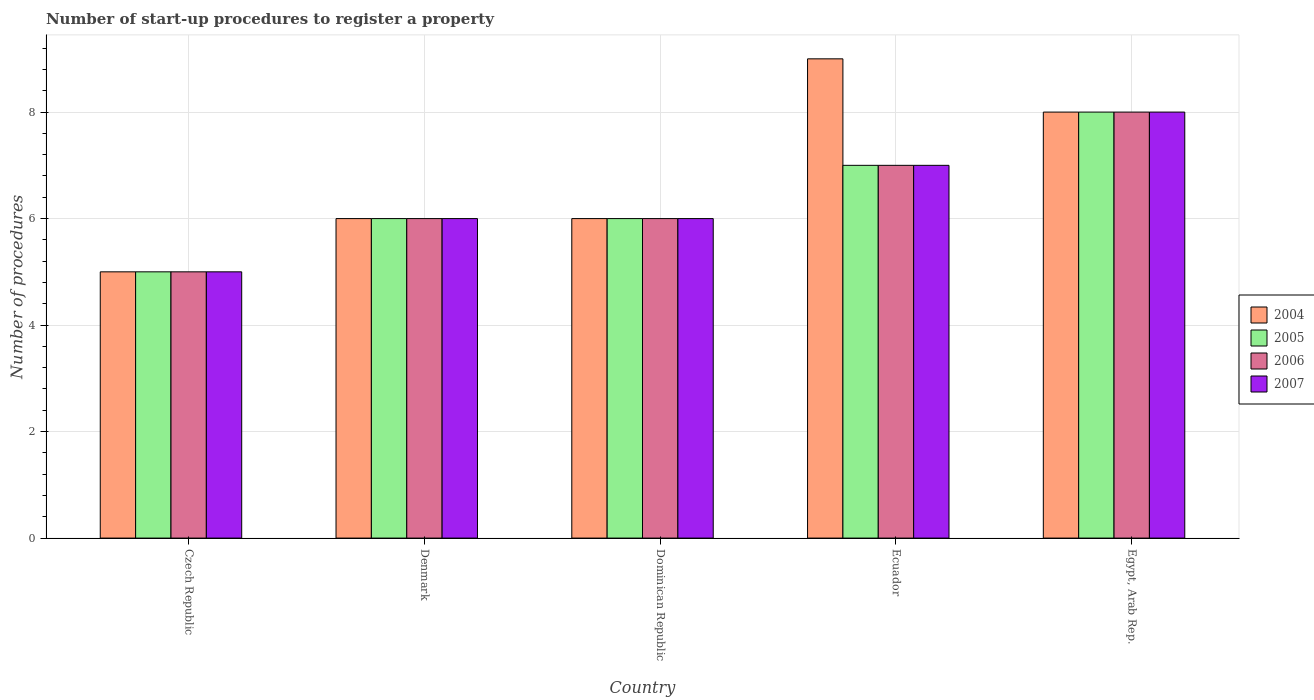How many different coloured bars are there?
Provide a short and direct response. 4. Are the number of bars on each tick of the X-axis equal?
Keep it short and to the point. Yes. What is the label of the 4th group of bars from the left?
Give a very brief answer. Ecuador. In which country was the number of procedures required to register a property in 2006 maximum?
Your response must be concise. Egypt, Arab Rep. In which country was the number of procedures required to register a property in 2005 minimum?
Provide a succinct answer. Czech Republic. What is the difference between the number of procedures required to register a property in 2004 in Dominican Republic and that in Egypt, Arab Rep.?
Provide a succinct answer. -2. What is the average number of procedures required to register a property in 2006 per country?
Your answer should be compact. 6.4. What is the difference between the number of procedures required to register a property of/in 2005 and number of procedures required to register a property of/in 2004 in Ecuador?
Give a very brief answer. -2. In how many countries, is the number of procedures required to register a property in 2007 greater than 3.6?
Offer a very short reply. 5. What is the ratio of the number of procedures required to register a property in 2006 in Dominican Republic to that in Ecuador?
Offer a very short reply. 0.86. What is the difference between the highest and the second highest number of procedures required to register a property in 2007?
Make the answer very short. 2. What is the difference between the highest and the lowest number of procedures required to register a property in 2005?
Provide a succinct answer. 3. In how many countries, is the number of procedures required to register a property in 2004 greater than the average number of procedures required to register a property in 2004 taken over all countries?
Your answer should be compact. 2. Is the sum of the number of procedures required to register a property in 2005 in Denmark and Egypt, Arab Rep. greater than the maximum number of procedures required to register a property in 2007 across all countries?
Offer a terse response. Yes. Is it the case that in every country, the sum of the number of procedures required to register a property in 2005 and number of procedures required to register a property in 2006 is greater than the sum of number of procedures required to register a property in 2004 and number of procedures required to register a property in 2007?
Your answer should be very brief. No. What does the 1st bar from the left in Czech Republic represents?
Offer a very short reply. 2004. What does the 4th bar from the right in Ecuador represents?
Offer a terse response. 2004. Is it the case that in every country, the sum of the number of procedures required to register a property in 2004 and number of procedures required to register a property in 2005 is greater than the number of procedures required to register a property in 2006?
Ensure brevity in your answer.  Yes. How many bars are there?
Your answer should be very brief. 20. Are all the bars in the graph horizontal?
Provide a short and direct response. No. Does the graph contain grids?
Your answer should be compact. Yes. Where does the legend appear in the graph?
Your response must be concise. Center right. How many legend labels are there?
Offer a terse response. 4. How are the legend labels stacked?
Your response must be concise. Vertical. What is the title of the graph?
Your response must be concise. Number of start-up procedures to register a property. What is the label or title of the X-axis?
Offer a very short reply. Country. What is the label or title of the Y-axis?
Provide a succinct answer. Number of procedures. What is the Number of procedures in 2004 in Czech Republic?
Your answer should be very brief. 5. What is the Number of procedures of 2005 in Czech Republic?
Give a very brief answer. 5. What is the Number of procedures of 2007 in Denmark?
Provide a succinct answer. 6. What is the Number of procedures in 2004 in Dominican Republic?
Give a very brief answer. 6. What is the Number of procedures of 2005 in Dominican Republic?
Your response must be concise. 6. What is the Number of procedures of 2007 in Dominican Republic?
Provide a succinct answer. 6. What is the Number of procedures in 2004 in Ecuador?
Provide a short and direct response. 9. What is the Number of procedures of 2007 in Ecuador?
Offer a terse response. 7. What is the Number of procedures in 2004 in Egypt, Arab Rep.?
Provide a succinct answer. 8. What is the Number of procedures of 2005 in Egypt, Arab Rep.?
Your response must be concise. 8. What is the Number of procedures of 2006 in Egypt, Arab Rep.?
Your response must be concise. 8. What is the Number of procedures in 2007 in Egypt, Arab Rep.?
Keep it short and to the point. 8. Across all countries, what is the maximum Number of procedures in 2004?
Your response must be concise. 9. Across all countries, what is the maximum Number of procedures of 2005?
Offer a terse response. 8. Across all countries, what is the maximum Number of procedures in 2007?
Provide a short and direct response. 8. Across all countries, what is the minimum Number of procedures of 2006?
Provide a short and direct response. 5. What is the total Number of procedures of 2004 in the graph?
Provide a succinct answer. 34. What is the total Number of procedures of 2005 in the graph?
Offer a terse response. 32. What is the total Number of procedures of 2007 in the graph?
Make the answer very short. 32. What is the difference between the Number of procedures in 2005 in Czech Republic and that in Dominican Republic?
Ensure brevity in your answer.  -1. What is the difference between the Number of procedures in 2006 in Czech Republic and that in Dominican Republic?
Make the answer very short. -1. What is the difference between the Number of procedures of 2007 in Czech Republic and that in Dominican Republic?
Provide a short and direct response. -1. What is the difference between the Number of procedures of 2004 in Czech Republic and that in Ecuador?
Provide a succinct answer. -4. What is the difference between the Number of procedures of 2007 in Czech Republic and that in Ecuador?
Your response must be concise. -2. What is the difference between the Number of procedures in 2005 in Czech Republic and that in Egypt, Arab Rep.?
Your response must be concise. -3. What is the difference between the Number of procedures in 2007 in Czech Republic and that in Egypt, Arab Rep.?
Provide a short and direct response. -3. What is the difference between the Number of procedures of 2006 in Denmark and that in Dominican Republic?
Ensure brevity in your answer.  0. What is the difference between the Number of procedures of 2004 in Denmark and that in Ecuador?
Offer a terse response. -3. What is the difference between the Number of procedures of 2007 in Denmark and that in Ecuador?
Make the answer very short. -1. What is the difference between the Number of procedures of 2004 in Denmark and that in Egypt, Arab Rep.?
Ensure brevity in your answer.  -2. What is the difference between the Number of procedures of 2005 in Denmark and that in Egypt, Arab Rep.?
Provide a succinct answer. -2. What is the difference between the Number of procedures of 2007 in Denmark and that in Egypt, Arab Rep.?
Ensure brevity in your answer.  -2. What is the difference between the Number of procedures of 2007 in Dominican Republic and that in Ecuador?
Keep it short and to the point. -1. What is the difference between the Number of procedures of 2005 in Dominican Republic and that in Egypt, Arab Rep.?
Your response must be concise. -2. What is the difference between the Number of procedures of 2007 in Dominican Republic and that in Egypt, Arab Rep.?
Your response must be concise. -2. What is the difference between the Number of procedures in 2006 in Ecuador and that in Egypt, Arab Rep.?
Keep it short and to the point. -1. What is the difference between the Number of procedures of 2004 in Czech Republic and the Number of procedures of 2005 in Denmark?
Make the answer very short. -1. What is the difference between the Number of procedures of 2004 in Czech Republic and the Number of procedures of 2007 in Denmark?
Give a very brief answer. -1. What is the difference between the Number of procedures of 2005 in Czech Republic and the Number of procedures of 2007 in Denmark?
Keep it short and to the point. -1. What is the difference between the Number of procedures in 2004 in Czech Republic and the Number of procedures in 2006 in Dominican Republic?
Provide a succinct answer. -1. What is the difference between the Number of procedures of 2004 in Czech Republic and the Number of procedures of 2007 in Dominican Republic?
Give a very brief answer. -1. What is the difference between the Number of procedures of 2005 in Czech Republic and the Number of procedures of 2007 in Dominican Republic?
Keep it short and to the point. -1. What is the difference between the Number of procedures in 2006 in Czech Republic and the Number of procedures in 2007 in Dominican Republic?
Keep it short and to the point. -1. What is the difference between the Number of procedures of 2004 in Czech Republic and the Number of procedures of 2005 in Ecuador?
Your response must be concise. -2. What is the difference between the Number of procedures in 2004 in Czech Republic and the Number of procedures in 2007 in Ecuador?
Offer a terse response. -2. What is the difference between the Number of procedures of 2005 in Czech Republic and the Number of procedures of 2006 in Ecuador?
Make the answer very short. -2. What is the difference between the Number of procedures in 2006 in Czech Republic and the Number of procedures in 2007 in Ecuador?
Provide a short and direct response. -2. What is the difference between the Number of procedures of 2004 in Czech Republic and the Number of procedures of 2006 in Egypt, Arab Rep.?
Give a very brief answer. -3. What is the difference between the Number of procedures of 2004 in Czech Republic and the Number of procedures of 2007 in Egypt, Arab Rep.?
Your answer should be very brief. -3. What is the difference between the Number of procedures of 2005 in Czech Republic and the Number of procedures of 2006 in Egypt, Arab Rep.?
Your answer should be very brief. -3. What is the difference between the Number of procedures in 2004 in Denmark and the Number of procedures in 2006 in Dominican Republic?
Provide a succinct answer. 0. What is the difference between the Number of procedures of 2005 in Denmark and the Number of procedures of 2006 in Dominican Republic?
Offer a terse response. 0. What is the difference between the Number of procedures in 2004 in Denmark and the Number of procedures in 2005 in Ecuador?
Your answer should be compact. -1. What is the difference between the Number of procedures of 2004 in Denmark and the Number of procedures of 2006 in Ecuador?
Your answer should be very brief. -1. What is the difference between the Number of procedures of 2004 in Denmark and the Number of procedures of 2007 in Ecuador?
Your answer should be compact. -1. What is the difference between the Number of procedures in 2006 in Denmark and the Number of procedures in 2007 in Ecuador?
Provide a succinct answer. -1. What is the difference between the Number of procedures in 2004 in Denmark and the Number of procedures in 2007 in Egypt, Arab Rep.?
Your answer should be compact. -2. What is the difference between the Number of procedures in 2005 in Denmark and the Number of procedures in 2006 in Egypt, Arab Rep.?
Offer a very short reply. -2. What is the difference between the Number of procedures of 2005 in Dominican Republic and the Number of procedures of 2006 in Ecuador?
Give a very brief answer. -1. What is the difference between the Number of procedures in 2004 in Dominican Republic and the Number of procedures in 2005 in Egypt, Arab Rep.?
Offer a terse response. -2. What is the difference between the Number of procedures in 2004 in Dominican Republic and the Number of procedures in 2007 in Egypt, Arab Rep.?
Provide a short and direct response. -2. What is the difference between the Number of procedures in 2005 in Dominican Republic and the Number of procedures in 2006 in Egypt, Arab Rep.?
Keep it short and to the point. -2. What is the difference between the Number of procedures of 2006 in Dominican Republic and the Number of procedures of 2007 in Egypt, Arab Rep.?
Provide a short and direct response. -2. What is the difference between the Number of procedures of 2005 in Ecuador and the Number of procedures of 2007 in Egypt, Arab Rep.?
Provide a succinct answer. -1. What is the average Number of procedures in 2004 per country?
Provide a succinct answer. 6.8. What is the difference between the Number of procedures in 2004 and Number of procedures in 2005 in Czech Republic?
Your answer should be very brief. 0. What is the difference between the Number of procedures of 2004 and Number of procedures of 2006 in Czech Republic?
Ensure brevity in your answer.  0. What is the difference between the Number of procedures in 2005 and Number of procedures in 2006 in Czech Republic?
Offer a terse response. 0. What is the difference between the Number of procedures in 2005 and Number of procedures in 2007 in Czech Republic?
Ensure brevity in your answer.  0. What is the difference between the Number of procedures in 2004 and Number of procedures in 2005 in Denmark?
Your answer should be compact. 0. What is the difference between the Number of procedures of 2005 and Number of procedures of 2007 in Denmark?
Provide a short and direct response. 0. What is the difference between the Number of procedures in 2004 and Number of procedures in 2006 in Dominican Republic?
Offer a terse response. 0. What is the difference between the Number of procedures of 2004 and Number of procedures of 2007 in Dominican Republic?
Your answer should be very brief. 0. What is the difference between the Number of procedures in 2005 and Number of procedures in 2007 in Dominican Republic?
Your answer should be very brief. 0. What is the difference between the Number of procedures of 2004 and Number of procedures of 2006 in Ecuador?
Keep it short and to the point. 2. What is the difference between the Number of procedures of 2005 and Number of procedures of 2006 in Ecuador?
Keep it short and to the point. 0. What is the difference between the Number of procedures in 2006 and Number of procedures in 2007 in Egypt, Arab Rep.?
Keep it short and to the point. 0. What is the ratio of the Number of procedures of 2007 in Czech Republic to that in Denmark?
Your answer should be very brief. 0.83. What is the ratio of the Number of procedures in 2004 in Czech Republic to that in Dominican Republic?
Give a very brief answer. 0.83. What is the ratio of the Number of procedures of 2005 in Czech Republic to that in Dominican Republic?
Provide a short and direct response. 0.83. What is the ratio of the Number of procedures in 2006 in Czech Republic to that in Dominican Republic?
Provide a succinct answer. 0.83. What is the ratio of the Number of procedures in 2004 in Czech Republic to that in Ecuador?
Make the answer very short. 0.56. What is the ratio of the Number of procedures of 2005 in Czech Republic to that in Ecuador?
Make the answer very short. 0.71. What is the ratio of the Number of procedures in 2007 in Czech Republic to that in Ecuador?
Your answer should be very brief. 0.71. What is the ratio of the Number of procedures of 2005 in Czech Republic to that in Egypt, Arab Rep.?
Your answer should be compact. 0.62. What is the ratio of the Number of procedures in 2004 in Denmark to that in Dominican Republic?
Offer a very short reply. 1. What is the ratio of the Number of procedures in 2006 in Denmark to that in Dominican Republic?
Your answer should be very brief. 1. What is the ratio of the Number of procedures of 2005 in Denmark to that in Ecuador?
Provide a succinct answer. 0.86. What is the ratio of the Number of procedures in 2006 in Denmark to that in Ecuador?
Give a very brief answer. 0.86. What is the ratio of the Number of procedures in 2005 in Denmark to that in Egypt, Arab Rep.?
Ensure brevity in your answer.  0.75. What is the ratio of the Number of procedures in 2006 in Denmark to that in Egypt, Arab Rep.?
Your response must be concise. 0.75. What is the ratio of the Number of procedures of 2007 in Denmark to that in Egypt, Arab Rep.?
Give a very brief answer. 0.75. What is the ratio of the Number of procedures in 2004 in Dominican Republic to that in Ecuador?
Provide a succinct answer. 0.67. What is the ratio of the Number of procedures in 2005 in Dominican Republic to that in Ecuador?
Keep it short and to the point. 0.86. What is the ratio of the Number of procedures of 2007 in Dominican Republic to that in Ecuador?
Offer a terse response. 0.86. What is the ratio of the Number of procedures of 2006 in Dominican Republic to that in Egypt, Arab Rep.?
Offer a terse response. 0.75. What is the ratio of the Number of procedures in 2007 in Dominican Republic to that in Egypt, Arab Rep.?
Ensure brevity in your answer.  0.75. What is the ratio of the Number of procedures in 2006 in Ecuador to that in Egypt, Arab Rep.?
Your response must be concise. 0.88. What is the ratio of the Number of procedures in 2007 in Ecuador to that in Egypt, Arab Rep.?
Make the answer very short. 0.88. What is the difference between the highest and the second highest Number of procedures of 2005?
Give a very brief answer. 1. What is the difference between the highest and the lowest Number of procedures of 2005?
Ensure brevity in your answer.  3. What is the difference between the highest and the lowest Number of procedures in 2006?
Your answer should be compact. 3. What is the difference between the highest and the lowest Number of procedures in 2007?
Your response must be concise. 3. 